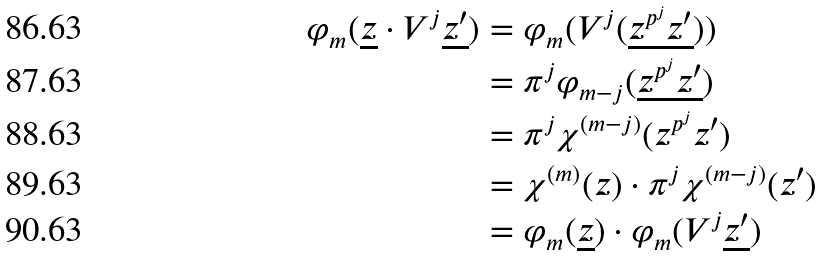Convert formula to latex. <formula><loc_0><loc_0><loc_500><loc_500>\varphi _ { m } ( \underline { z } \cdot V ^ { j } \underline { z ^ { \prime } } ) & = \varphi _ { m } ( V ^ { j } ( \underline { z ^ { p ^ { j } } z ^ { \prime } } ) ) \\ & = \pi ^ { j } \varphi _ { m - j } ( \underline { z ^ { p ^ { j } } z ^ { \prime } } ) \\ & = \pi ^ { j } \chi ^ { ( m - j ) } ( z ^ { p ^ { j } } z ^ { \prime } ) \\ & = \chi ^ { ( m ) } ( z ) \cdot \pi ^ { j } \chi ^ { ( m - j ) } ( z ^ { \prime } ) \\ & = \varphi _ { m } ( \underline { z } ) \cdot \varphi _ { m } ( V ^ { j } \underline { z ^ { \prime } } )</formula> 